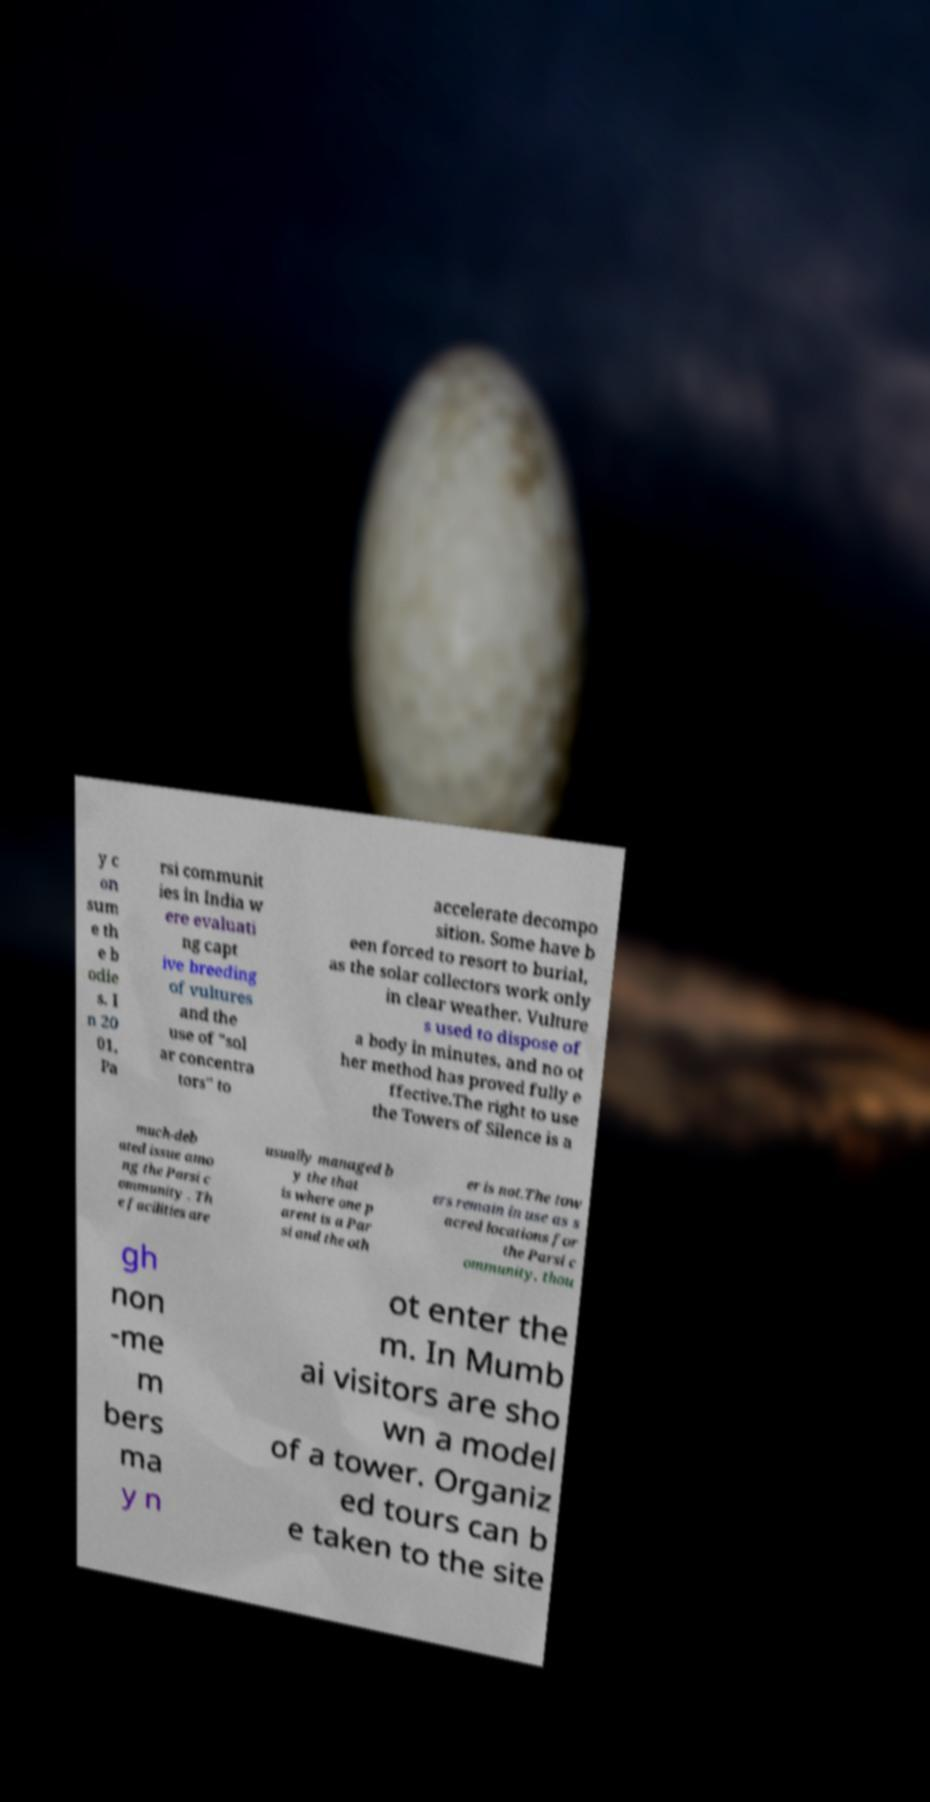What messages or text are displayed in this image? I need them in a readable, typed format. y c on sum e th e b odie s. I n 20 01, Pa rsi communit ies in India w ere evaluati ng capt ive breeding of vultures and the use of "sol ar concentra tors" to accelerate decompo sition. Some have b een forced to resort to burial, as the solar collectors work only in clear weather. Vulture s used to dispose of a body in minutes, and no ot her method has proved fully e ffective.The right to use the Towers of Silence is a much-deb ated issue amo ng the Parsi c ommunity . Th e facilities are usually managed b y the that is where one p arent is a Par si and the oth er is not.The tow ers remain in use as s acred locations for the Parsi c ommunity, thou gh non -me m bers ma y n ot enter the m. In Mumb ai visitors are sho wn a model of a tower. Organiz ed tours can b e taken to the site 